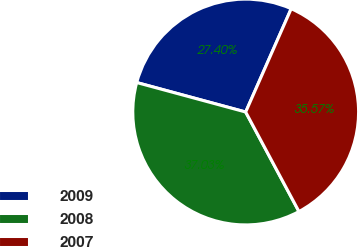Convert chart to OTSL. <chart><loc_0><loc_0><loc_500><loc_500><pie_chart><fcel>2009<fcel>2008<fcel>2007<nl><fcel>27.4%<fcel>37.03%<fcel>35.57%<nl></chart> 